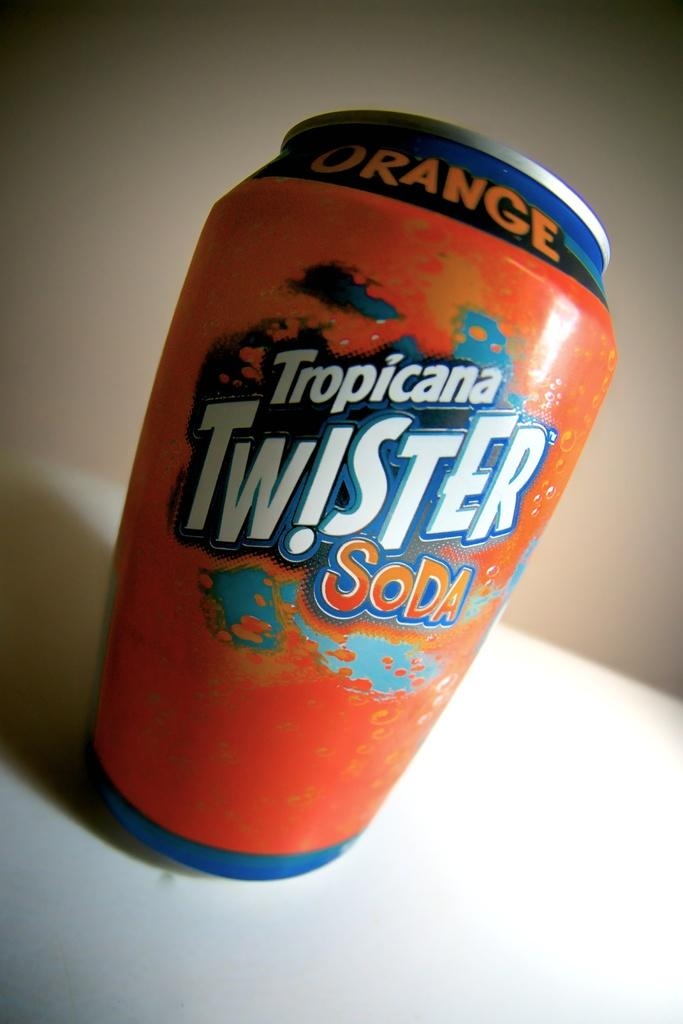Provide a one-sentence caption for the provided image. Tropicana Twister Soda comes in a bright orange can. 